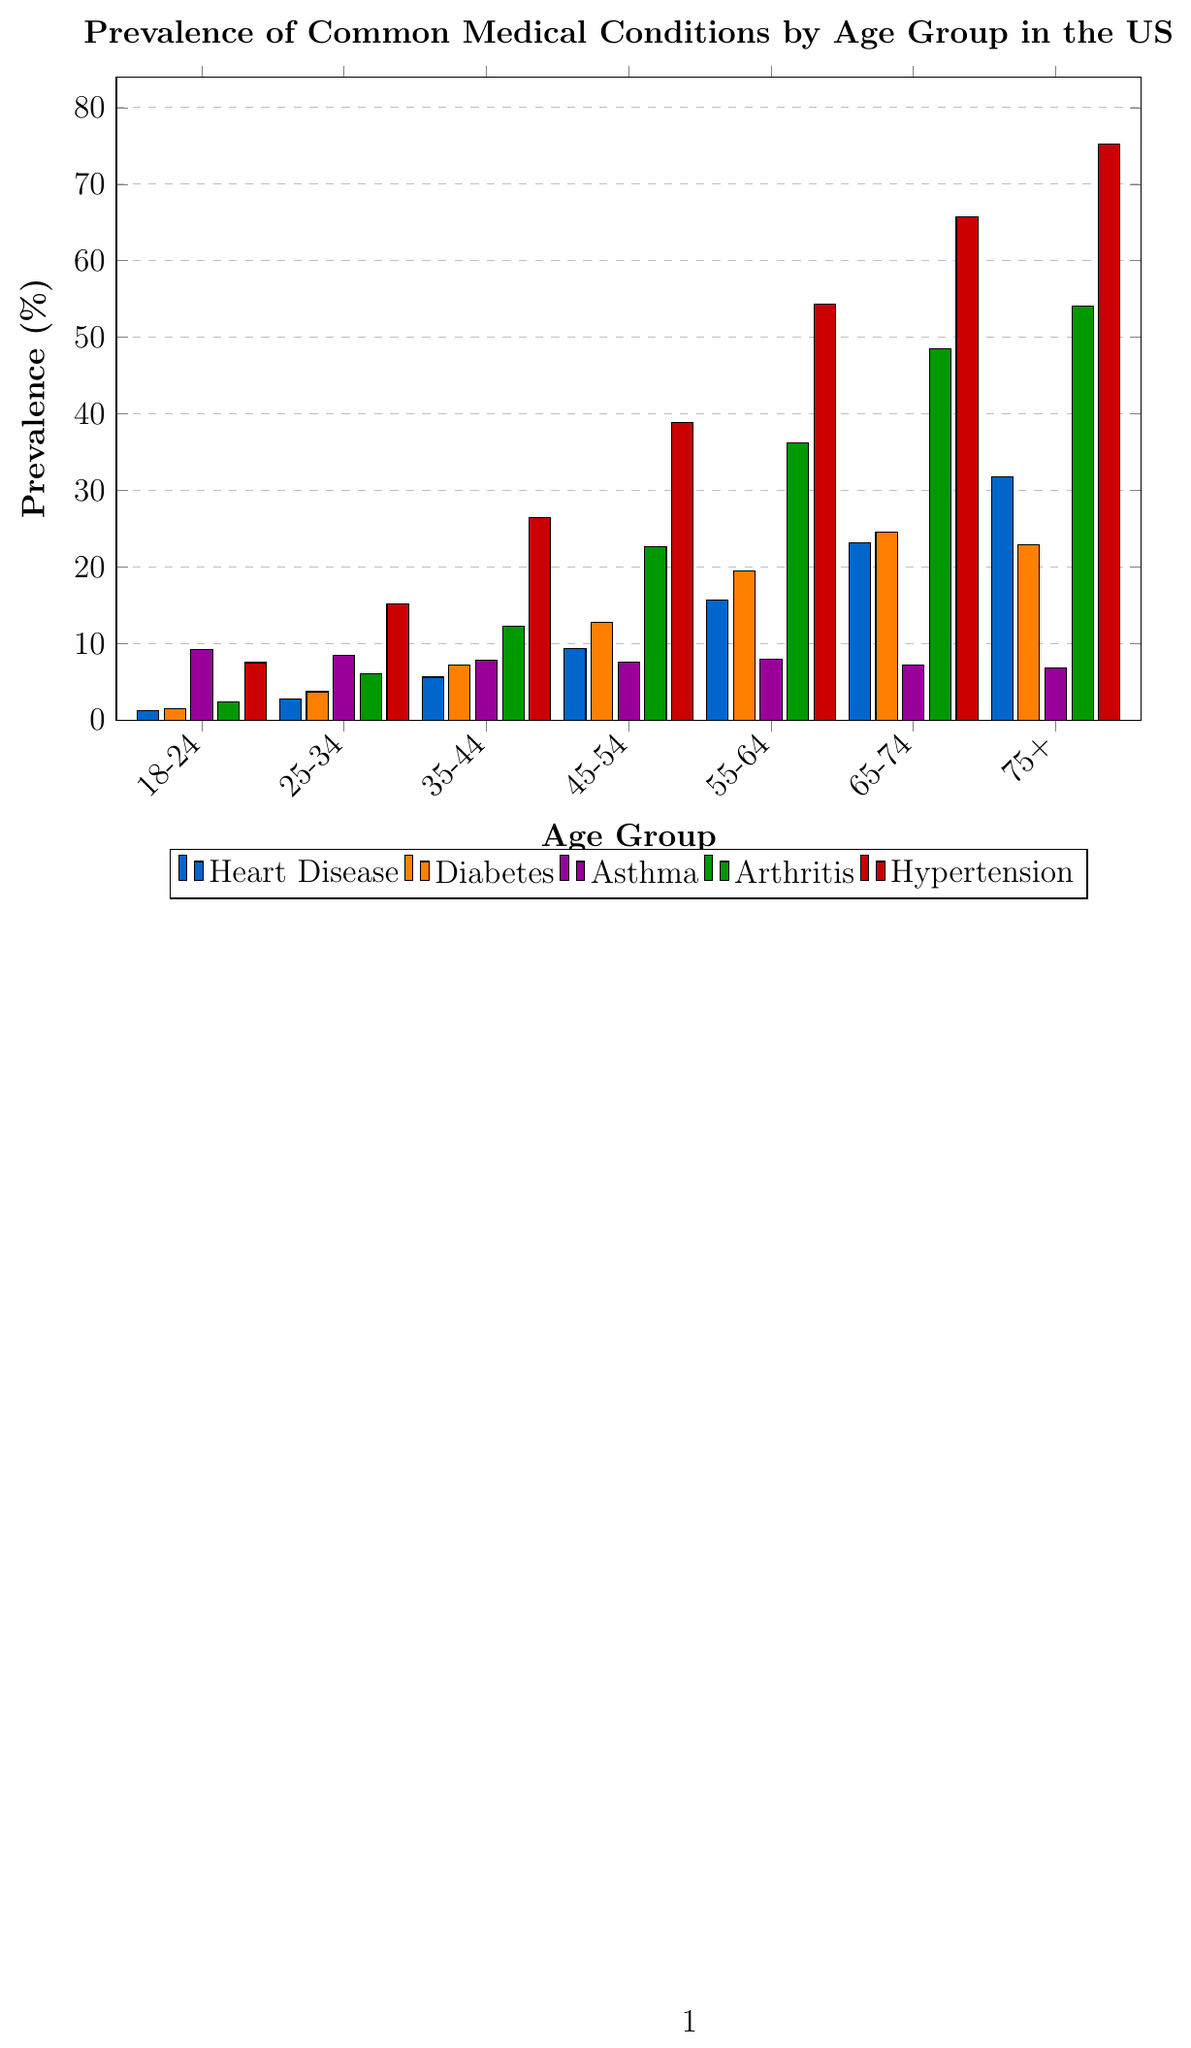Which age group has the highest prevalence of hypertension? By observing the height of the bars representing hypertension, the 75+ age group has the tallest bar indicating the highest prevalence.
Answer: 75+ Which age group sees the biggest increase in arthritis prevalence from the previous group? Compare the differences in arthritis prevalence between successive age groups. The largest increase occurs between 55-64 and 65-74, where it jumps from 36.2% to 48.5%.
Answer: 55-64 to 65-74 How does the prevalence of asthma change across age groups? Observe the height of the bars representing asthma for each age group. Initially, it decreases from 9.2% to 6.8% but is relatively stable around 7-9% across all age groups.
Answer: Relatively stable, slight decrease Which condition has the highest prevalence in the 65-74 age group? Assess the bars in the 65-74 age group, with hypertension having the highest bar representing a prevalence of 65.7%.
Answer: Hypertension What is the average prevalence of diabetes across all age groups? Add the prevalence values for diabetes across all age groups (1.5 + 3.7 + 7.2 + 12.8 + 19.5 + 24.6 + 22.9) and divide by the number of age groups, which is 7. The calculation is (1.5 + 3.7 + 7.2 + 12.8 + 19.5 + 24.6 + 22.9)/7 = 13.17%.
Answer: 13.17% Compare the prevalence of heart disease and arthritis in the 55-64 age group. Which one is more common? Look at the heights of the bars for heart disease and arthritis in the 55-64 age group. Arthritis is more common with a prevalence of 36.2%, compared to heart disease at 15.7%.
Answer: Arthritis What is the total prevalence value sum of conditions for the 18-24 age group? Sum the prevalence values for all conditions in the 18-24 age group: Heart Disease (1.2) + Diabetes (1.5) + Asthma (9.2) + Arthritis (2.4) + Hypertension (7.5). The sum is 1.2 + 1.5 + 9.2 + 2.4 + 7.5 = 21.8%.
Answer: 21.8% Which age group has the smallest difference in prevalence between heart disease and diabetes? Calculate the difference between heart disease and diabetes for each age group, then find the smallest difference. The smallest difference is in the 75+ age group with 31.8%-22.9% = 8.9%.
Answer: 75+ Is the prevalence of diabetes higher or lower than asthma in the 35-44 age group? Compare the heights of the bars for diabetes and asthma in the 35-44 age group, with diabetes at 7.2% and asthma at 7.8%. Diabetes is lower.
Answer: Lower How does the prevalence of heart disease change from the 45-54 to 65-74 age groups? Observe the increase in prevalence of heart disease from 45-54 (9.3%) to 55-64 (15.7%) to 65-74 (23.2%), showing a consistent increase.
Answer: Consistent increase 